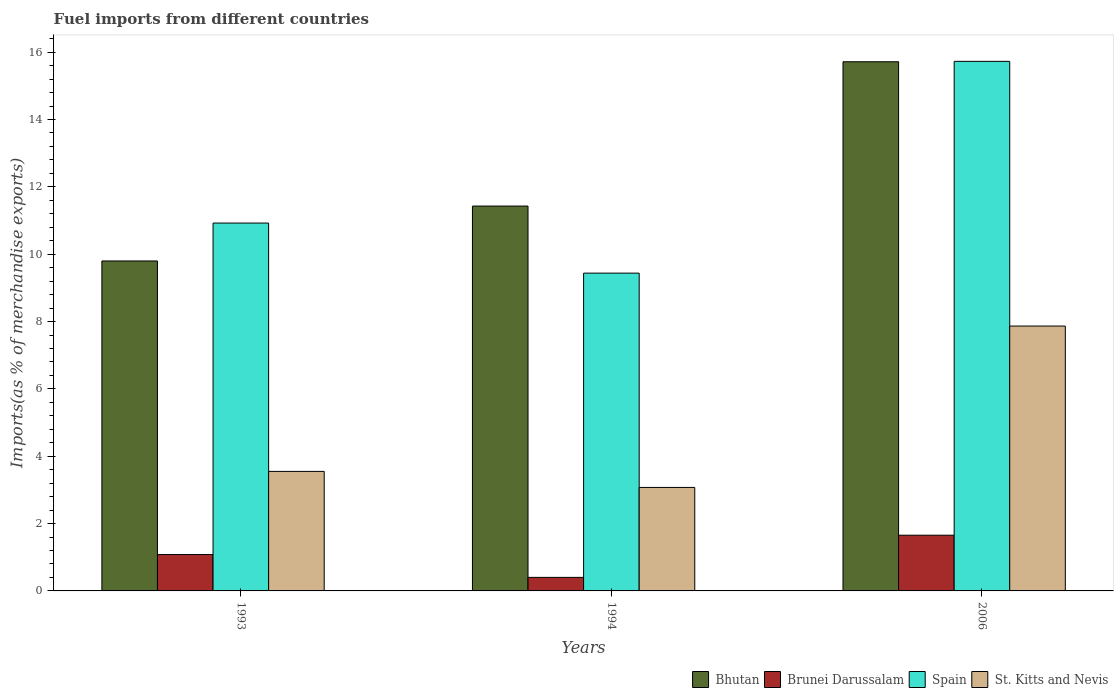How many different coloured bars are there?
Your answer should be very brief. 4. Are the number of bars per tick equal to the number of legend labels?
Your answer should be compact. Yes. Are the number of bars on each tick of the X-axis equal?
Provide a succinct answer. Yes. How many bars are there on the 1st tick from the right?
Offer a terse response. 4. What is the percentage of imports to different countries in Bhutan in 1993?
Offer a very short reply. 9.8. Across all years, what is the maximum percentage of imports to different countries in Brunei Darussalam?
Your answer should be compact. 1.65. Across all years, what is the minimum percentage of imports to different countries in Bhutan?
Keep it short and to the point. 9.8. In which year was the percentage of imports to different countries in Spain maximum?
Make the answer very short. 2006. In which year was the percentage of imports to different countries in St. Kitts and Nevis minimum?
Your response must be concise. 1994. What is the total percentage of imports to different countries in St. Kitts and Nevis in the graph?
Make the answer very short. 14.49. What is the difference between the percentage of imports to different countries in St. Kitts and Nevis in 1993 and that in 1994?
Provide a succinct answer. 0.48. What is the difference between the percentage of imports to different countries in Bhutan in 1993 and the percentage of imports to different countries in St. Kitts and Nevis in 1994?
Your response must be concise. 6.73. What is the average percentage of imports to different countries in Brunei Darussalam per year?
Provide a short and direct response. 1.05. In the year 2006, what is the difference between the percentage of imports to different countries in Bhutan and percentage of imports to different countries in St. Kitts and Nevis?
Offer a terse response. 7.85. In how many years, is the percentage of imports to different countries in St. Kitts and Nevis greater than 2.4 %?
Provide a short and direct response. 3. What is the ratio of the percentage of imports to different countries in Spain in 1993 to that in 1994?
Give a very brief answer. 1.16. Is the percentage of imports to different countries in Bhutan in 1994 less than that in 2006?
Your answer should be compact. Yes. Is the difference between the percentage of imports to different countries in Bhutan in 1993 and 1994 greater than the difference between the percentage of imports to different countries in St. Kitts and Nevis in 1993 and 1994?
Provide a succinct answer. No. What is the difference between the highest and the second highest percentage of imports to different countries in Spain?
Your answer should be compact. 4.8. What is the difference between the highest and the lowest percentage of imports to different countries in St. Kitts and Nevis?
Provide a succinct answer. 4.79. In how many years, is the percentage of imports to different countries in Brunei Darussalam greater than the average percentage of imports to different countries in Brunei Darussalam taken over all years?
Offer a very short reply. 2. Is the sum of the percentage of imports to different countries in St. Kitts and Nevis in 1993 and 2006 greater than the maximum percentage of imports to different countries in Bhutan across all years?
Give a very brief answer. No. What does the 3rd bar from the left in 2006 represents?
Keep it short and to the point. Spain. What does the 4th bar from the right in 1993 represents?
Your response must be concise. Bhutan. Are all the bars in the graph horizontal?
Your response must be concise. No. Are the values on the major ticks of Y-axis written in scientific E-notation?
Offer a very short reply. No. How are the legend labels stacked?
Keep it short and to the point. Horizontal. What is the title of the graph?
Keep it short and to the point. Fuel imports from different countries. What is the label or title of the Y-axis?
Provide a short and direct response. Imports(as % of merchandise exports). What is the Imports(as % of merchandise exports) of Bhutan in 1993?
Your answer should be compact. 9.8. What is the Imports(as % of merchandise exports) of Brunei Darussalam in 1993?
Provide a short and direct response. 1.08. What is the Imports(as % of merchandise exports) in Spain in 1993?
Your answer should be very brief. 10.92. What is the Imports(as % of merchandise exports) of St. Kitts and Nevis in 1993?
Your answer should be very brief. 3.55. What is the Imports(as % of merchandise exports) in Bhutan in 1994?
Provide a succinct answer. 11.43. What is the Imports(as % of merchandise exports) in Brunei Darussalam in 1994?
Give a very brief answer. 0.4. What is the Imports(as % of merchandise exports) of Spain in 1994?
Your answer should be compact. 9.44. What is the Imports(as % of merchandise exports) in St. Kitts and Nevis in 1994?
Make the answer very short. 3.07. What is the Imports(as % of merchandise exports) in Bhutan in 2006?
Make the answer very short. 15.71. What is the Imports(as % of merchandise exports) in Brunei Darussalam in 2006?
Your answer should be very brief. 1.65. What is the Imports(as % of merchandise exports) in Spain in 2006?
Provide a succinct answer. 15.73. What is the Imports(as % of merchandise exports) in St. Kitts and Nevis in 2006?
Keep it short and to the point. 7.87. Across all years, what is the maximum Imports(as % of merchandise exports) of Bhutan?
Provide a short and direct response. 15.71. Across all years, what is the maximum Imports(as % of merchandise exports) in Brunei Darussalam?
Keep it short and to the point. 1.65. Across all years, what is the maximum Imports(as % of merchandise exports) in Spain?
Keep it short and to the point. 15.73. Across all years, what is the maximum Imports(as % of merchandise exports) of St. Kitts and Nevis?
Provide a succinct answer. 7.87. Across all years, what is the minimum Imports(as % of merchandise exports) in Bhutan?
Keep it short and to the point. 9.8. Across all years, what is the minimum Imports(as % of merchandise exports) in Brunei Darussalam?
Keep it short and to the point. 0.4. Across all years, what is the minimum Imports(as % of merchandise exports) in Spain?
Make the answer very short. 9.44. Across all years, what is the minimum Imports(as % of merchandise exports) in St. Kitts and Nevis?
Offer a very short reply. 3.07. What is the total Imports(as % of merchandise exports) in Bhutan in the graph?
Your answer should be very brief. 36.94. What is the total Imports(as % of merchandise exports) in Brunei Darussalam in the graph?
Keep it short and to the point. 3.14. What is the total Imports(as % of merchandise exports) in Spain in the graph?
Give a very brief answer. 36.09. What is the total Imports(as % of merchandise exports) of St. Kitts and Nevis in the graph?
Your response must be concise. 14.49. What is the difference between the Imports(as % of merchandise exports) in Bhutan in 1993 and that in 1994?
Your answer should be very brief. -1.63. What is the difference between the Imports(as % of merchandise exports) in Brunei Darussalam in 1993 and that in 1994?
Your response must be concise. 0.68. What is the difference between the Imports(as % of merchandise exports) of Spain in 1993 and that in 1994?
Ensure brevity in your answer.  1.49. What is the difference between the Imports(as % of merchandise exports) in St. Kitts and Nevis in 1993 and that in 1994?
Ensure brevity in your answer.  0.48. What is the difference between the Imports(as % of merchandise exports) in Bhutan in 1993 and that in 2006?
Provide a short and direct response. -5.92. What is the difference between the Imports(as % of merchandise exports) in Brunei Darussalam in 1993 and that in 2006?
Provide a succinct answer. -0.57. What is the difference between the Imports(as % of merchandise exports) of Spain in 1993 and that in 2006?
Your answer should be very brief. -4.8. What is the difference between the Imports(as % of merchandise exports) in St. Kitts and Nevis in 1993 and that in 2006?
Your answer should be compact. -4.32. What is the difference between the Imports(as % of merchandise exports) in Bhutan in 1994 and that in 2006?
Your response must be concise. -4.29. What is the difference between the Imports(as % of merchandise exports) in Brunei Darussalam in 1994 and that in 2006?
Ensure brevity in your answer.  -1.25. What is the difference between the Imports(as % of merchandise exports) in Spain in 1994 and that in 2006?
Your response must be concise. -6.29. What is the difference between the Imports(as % of merchandise exports) of St. Kitts and Nevis in 1994 and that in 2006?
Offer a terse response. -4.79. What is the difference between the Imports(as % of merchandise exports) of Bhutan in 1993 and the Imports(as % of merchandise exports) of Brunei Darussalam in 1994?
Offer a very short reply. 9.4. What is the difference between the Imports(as % of merchandise exports) in Bhutan in 1993 and the Imports(as % of merchandise exports) in Spain in 1994?
Ensure brevity in your answer.  0.36. What is the difference between the Imports(as % of merchandise exports) of Bhutan in 1993 and the Imports(as % of merchandise exports) of St. Kitts and Nevis in 1994?
Provide a short and direct response. 6.73. What is the difference between the Imports(as % of merchandise exports) of Brunei Darussalam in 1993 and the Imports(as % of merchandise exports) of Spain in 1994?
Ensure brevity in your answer.  -8.36. What is the difference between the Imports(as % of merchandise exports) of Brunei Darussalam in 1993 and the Imports(as % of merchandise exports) of St. Kitts and Nevis in 1994?
Offer a terse response. -1.99. What is the difference between the Imports(as % of merchandise exports) of Spain in 1993 and the Imports(as % of merchandise exports) of St. Kitts and Nevis in 1994?
Give a very brief answer. 7.85. What is the difference between the Imports(as % of merchandise exports) in Bhutan in 1993 and the Imports(as % of merchandise exports) in Brunei Darussalam in 2006?
Your answer should be very brief. 8.14. What is the difference between the Imports(as % of merchandise exports) of Bhutan in 1993 and the Imports(as % of merchandise exports) of Spain in 2006?
Ensure brevity in your answer.  -5.93. What is the difference between the Imports(as % of merchandise exports) of Bhutan in 1993 and the Imports(as % of merchandise exports) of St. Kitts and Nevis in 2006?
Your response must be concise. 1.93. What is the difference between the Imports(as % of merchandise exports) of Brunei Darussalam in 1993 and the Imports(as % of merchandise exports) of Spain in 2006?
Your answer should be very brief. -14.65. What is the difference between the Imports(as % of merchandise exports) in Brunei Darussalam in 1993 and the Imports(as % of merchandise exports) in St. Kitts and Nevis in 2006?
Give a very brief answer. -6.79. What is the difference between the Imports(as % of merchandise exports) of Spain in 1993 and the Imports(as % of merchandise exports) of St. Kitts and Nevis in 2006?
Keep it short and to the point. 3.06. What is the difference between the Imports(as % of merchandise exports) in Bhutan in 1994 and the Imports(as % of merchandise exports) in Brunei Darussalam in 2006?
Your answer should be very brief. 9.77. What is the difference between the Imports(as % of merchandise exports) of Bhutan in 1994 and the Imports(as % of merchandise exports) of Spain in 2006?
Your answer should be compact. -4.3. What is the difference between the Imports(as % of merchandise exports) in Bhutan in 1994 and the Imports(as % of merchandise exports) in St. Kitts and Nevis in 2006?
Make the answer very short. 3.56. What is the difference between the Imports(as % of merchandise exports) in Brunei Darussalam in 1994 and the Imports(as % of merchandise exports) in Spain in 2006?
Make the answer very short. -15.32. What is the difference between the Imports(as % of merchandise exports) in Brunei Darussalam in 1994 and the Imports(as % of merchandise exports) in St. Kitts and Nevis in 2006?
Provide a short and direct response. -7.46. What is the difference between the Imports(as % of merchandise exports) in Spain in 1994 and the Imports(as % of merchandise exports) in St. Kitts and Nevis in 2006?
Offer a terse response. 1.57. What is the average Imports(as % of merchandise exports) of Bhutan per year?
Your answer should be very brief. 12.31. What is the average Imports(as % of merchandise exports) in Brunei Darussalam per year?
Make the answer very short. 1.05. What is the average Imports(as % of merchandise exports) of Spain per year?
Provide a short and direct response. 12.03. What is the average Imports(as % of merchandise exports) in St. Kitts and Nevis per year?
Provide a succinct answer. 4.83. In the year 1993, what is the difference between the Imports(as % of merchandise exports) of Bhutan and Imports(as % of merchandise exports) of Brunei Darussalam?
Your answer should be very brief. 8.72. In the year 1993, what is the difference between the Imports(as % of merchandise exports) of Bhutan and Imports(as % of merchandise exports) of Spain?
Give a very brief answer. -1.13. In the year 1993, what is the difference between the Imports(as % of merchandise exports) in Bhutan and Imports(as % of merchandise exports) in St. Kitts and Nevis?
Keep it short and to the point. 6.25. In the year 1993, what is the difference between the Imports(as % of merchandise exports) in Brunei Darussalam and Imports(as % of merchandise exports) in Spain?
Keep it short and to the point. -9.84. In the year 1993, what is the difference between the Imports(as % of merchandise exports) of Brunei Darussalam and Imports(as % of merchandise exports) of St. Kitts and Nevis?
Provide a short and direct response. -2.47. In the year 1993, what is the difference between the Imports(as % of merchandise exports) in Spain and Imports(as % of merchandise exports) in St. Kitts and Nevis?
Your answer should be very brief. 7.37. In the year 1994, what is the difference between the Imports(as % of merchandise exports) of Bhutan and Imports(as % of merchandise exports) of Brunei Darussalam?
Provide a short and direct response. 11.03. In the year 1994, what is the difference between the Imports(as % of merchandise exports) in Bhutan and Imports(as % of merchandise exports) in Spain?
Keep it short and to the point. 1.99. In the year 1994, what is the difference between the Imports(as % of merchandise exports) of Bhutan and Imports(as % of merchandise exports) of St. Kitts and Nevis?
Make the answer very short. 8.36. In the year 1994, what is the difference between the Imports(as % of merchandise exports) in Brunei Darussalam and Imports(as % of merchandise exports) in Spain?
Your answer should be compact. -9.04. In the year 1994, what is the difference between the Imports(as % of merchandise exports) of Brunei Darussalam and Imports(as % of merchandise exports) of St. Kitts and Nevis?
Your response must be concise. -2.67. In the year 1994, what is the difference between the Imports(as % of merchandise exports) in Spain and Imports(as % of merchandise exports) in St. Kitts and Nevis?
Ensure brevity in your answer.  6.36. In the year 2006, what is the difference between the Imports(as % of merchandise exports) of Bhutan and Imports(as % of merchandise exports) of Brunei Darussalam?
Keep it short and to the point. 14.06. In the year 2006, what is the difference between the Imports(as % of merchandise exports) in Bhutan and Imports(as % of merchandise exports) in Spain?
Keep it short and to the point. -0.01. In the year 2006, what is the difference between the Imports(as % of merchandise exports) of Bhutan and Imports(as % of merchandise exports) of St. Kitts and Nevis?
Your response must be concise. 7.85. In the year 2006, what is the difference between the Imports(as % of merchandise exports) of Brunei Darussalam and Imports(as % of merchandise exports) of Spain?
Keep it short and to the point. -14.07. In the year 2006, what is the difference between the Imports(as % of merchandise exports) of Brunei Darussalam and Imports(as % of merchandise exports) of St. Kitts and Nevis?
Provide a short and direct response. -6.21. In the year 2006, what is the difference between the Imports(as % of merchandise exports) in Spain and Imports(as % of merchandise exports) in St. Kitts and Nevis?
Make the answer very short. 7.86. What is the ratio of the Imports(as % of merchandise exports) in Bhutan in 1993 to that in 1994?
Offer a very short reply. 0.86. What is the ratio of the Imports(as % of merchandise exports) of Brunei Darussalam in 1993 to that in 1994?
Offer a very short reply. 2.69. What is the ratio of the Imports(as % of merchandise exports) of Spain in 1993 to that in 1994?
Provide a succinct answer. 1.16. What is the ratio of the Imports(as % of merchandise exports) of St. Kitts and Nevis in 1993 to that in 1994?
Keep it short and to the point. 1.16. What is the ratio of the Imports(as % of merchandise exports) of Bhutan in 1993 to that in 2006?
Your answer should be compact. 0.62. What is the ratio of the Imports(as % of merchandise exports) of Brunei Darussalam in 1993 to that in 2006?
Your answer should be compact. 0.65. What is the ratio of the Imports(as % of merchandise exports) of Spain in 1993 to that in 2006?
Give a very brief answer. 0.69. What is the ratio of the Imports(as % of merchandise exports) in St. Kitts and Nevis in 1993 to that in 2006?
Provide a short and direct response. 0.45. What is the ratio of the Imports(as % of merchandise exports) in Bhutan in 1994 to that in 2006?
Provide a short and direct response. 0.73. What is the ratio of the Imports(as % of merchandise exports) in Brunei Darussalam in 1994 to that in 2006?
Ensure brevity in your answer.  0.24. What is the ratio of the Imports(as % of merchandise exports) in Spain in 1994 to that in 2006?
Offer a very short reply. 0.6. What is the ratio of the Imports(as % of merchandise exports) of St. Kitts and Nevis in 1994 to that in 2006?
Your response must be concise. 0.39. What is the difference between the highest and the second highest Imports(as % of merchandise exports) in Bhutan?
Ensure brevity in your answer.  4.29. What is the difference between the highest and the second highest Imports(as % of merchandise exports) in Brunei Darussalam?
Offer a terse response. 0.57. What is the difference between the highest and the second highest Imports(as % of merchandise exports) of Spain?
Your answer should be compact. 4.8. What is the difference between the highest and the second highest Imports(as % of merchandise exports) in St. Kitts and Nevis?
Offer a very short reply. 4.32. What is the difference between the highest and the lowest Imports(as % of merchandise exports) of Bhutan?
Your answer should be very brief. 5.92. What is the difference between the highest and the lowest Imports(as % of merchandise exports) in Brunei Darussalam?
Your response must be concise. 1.25. What is the difference between the highest and the lowest Imports(as % of merchandise exports) of Spain?
Your response must be concise. 6.29. What is the difference between the highest and the lowest Imports(as % of merchandise exports) in St. Kitts and Nevis?
Offer a very short reply. 4.79. 